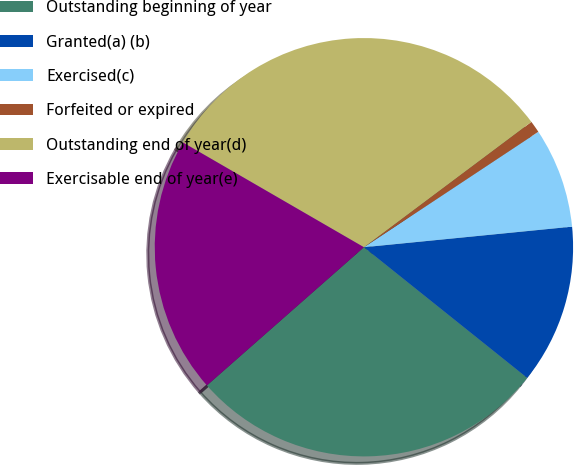Convert chart. <chart><loc_0><loc_0><loc_500><loc_500><pie_chart><fcel>Outstanding beginning of year<fcel>Granted(a) (b)<fcel>Exercised(c)<fcel>Forfeited or expired<fcel>Outstanding end of year(d)<fcel>Exercisable end of year(e)<nl><fcel>27.77%<fcel>12.31%<fcel>7.74%<fcel>0.92%<fcel>31.42%<fcel>19.84%<nl></chart> 